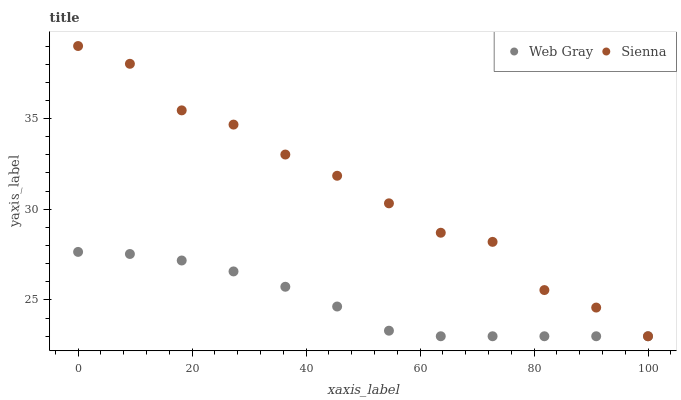Does Web Gray have the minimum area under the curve?
Answer yes or no. Yes. Does Sienna have the maximum area under the curve?
Answer yes or no. Yes. Does Web Gray have the maximum area under the curve?
Answer yes or no. No. Is Web Gray the smoothest?
Answer yes or no. Yes. Is Sienna the roughest?
Answer yes or no. Yes. Is Web Gray the roughest?
Answer yes or no. No. Does Sienna have the lowest value?
Answer yes or no. Yes. Does Sienna have the highest value?
Answer yes or no. Yes. Does Web Gray have the highest value?
Answer yes or no. No. Does Web Gray intersect Sienna?
Answer yes or no. Yes. Is Web Gray less than Sienna?
Answer yes or no. No. Is Web Gray greater than Sienna?
Answer yes or no. No. 